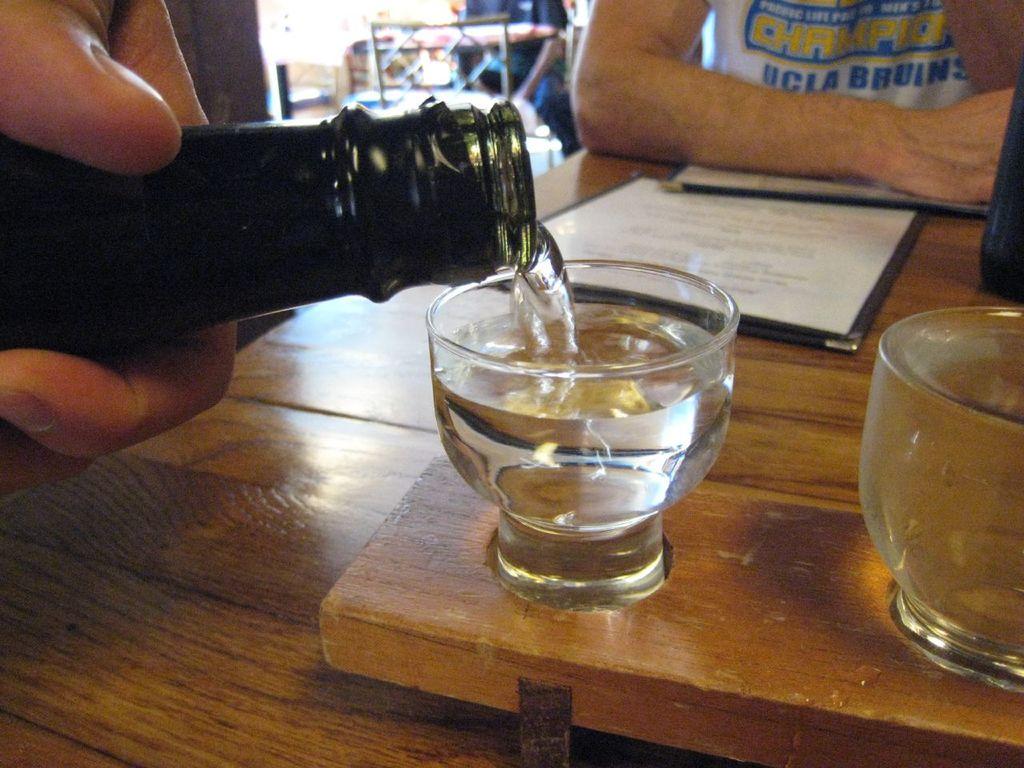What college is featured on the man's shirt?
Offer a very short reply. Ucla. What is ucla's mascot?
Provide a succinct answer. Bruins. 